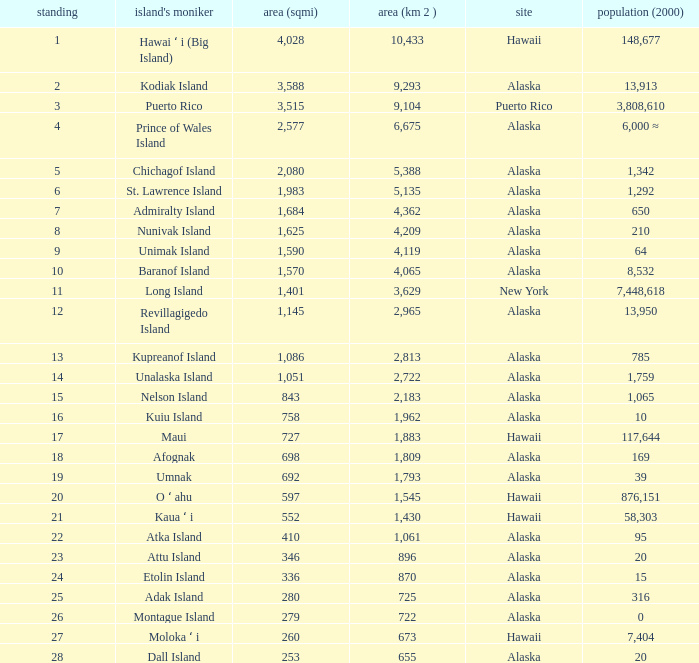Give me the full table as a dictionary. {'header': ['standing', "island's moniker", 'area (sqmi)', 'area (km 2 )', 'site', 'population (2000)'], 'rows': [['1', 'Hawai ʻ i (Big Island)', '4,028', '10,433', 'Hawaii', '148,677'], ['2', 'Kodiak Island', '3,588', '9,293', 'Alaska', '13,913'], ['3', 'Puerto Rico', '3,515', '9,104', 'Puerto Rico', '3,808,610'], ['4', 'Prince of Wales Island', '2,577', '6,675', 'Alaska', '6,000 ≈'], ['5', 'Chichagof Island', '2,080', '5,388', 'Alaska', '1,342'], ['6', 'St. Lawrence Island', '1,983', '5,135', 'Alaska', '1,292'], ['7', 'Admiralty Island', '1,684', '4,362', 'Alaska', '650'], ['8', 'Nunivak Island', '1,625', '4,209', 'Alaska', '210'], ['9', 'Unimak Island', '1,590', '4,119', 'Alaska', '64'], ['10', 'Baranof Island', '1,570', '4,065', 'Alaska', '8,532'], ['11', 'Long Island', '1,401', '3,629', 'New York', '7,448,618'], ['12', 'Revillagigedo Island', '1,145', '2,965', 'Alaska', '13,950'], ['13', 'Kupreanof Island', '1,086', '2,813', 'Alaska', '785'], ['14', 'Unalaska Island', '1,051', '2,722', 'Alaska', '1,759'], ['15', 'Nelson Island', '843', '2,183', 'Alaska', '1,065'], ['16', 'Kuiu Island', '758', '1,962', 'Alaska', '10'], ['17', 'Maui', '727', '1,883', 'Hawaii', '117,644'], ['18', 'Afognak', '698', '1,809', 'Alaska', '169'], ['19', 'Umnak', '692', '1,793', 'Alaska', '39'], ['20', 'O ʻ ahu', '597', '1,545', 'Hawaii', '876,151'], ['21', 'Kaua ʻ i', '552', '1,430', 'Hawaii', '58,303'], ['22', 'Atka Island', '410', '1,061', 'Alaska', '95'], ['23', 'Attu Island', '346', '896', 'Alaska', '20'], ['24', 'Etolin Island', '336', '870', 'Alaska', '15'], ['25', 'Adak Island', '280', '725', 'Alaska', '316'], ['26', 'Montague Island', '279', '722', 'Alaska', '0'], ['27', 'Moloka ʻ i', '260', '673', 'Hawaii', '7,404'], ['28', 'Dall Island', '253', '655', 'Alaska', '20']]} What is the largest rank with 2,080 area? 5.0. 